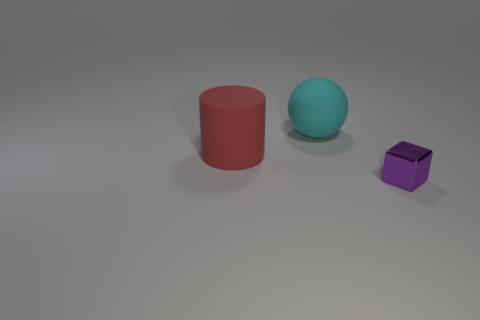There is a large object that is behind the big rubber cylinder; what is its material?
Your answer should be very brief. Rubber. Is there anything else that is made of the same material as the small purple object?
Offer a very short reply. No. Is the number of cylinders left of the shiny thing greater than the number of tiny yellow shiny blocks?
Keep it short and to the point. Yes. Are there any large matte things that are in front of the rubber thing behind the matte object that is left of the sphere?
Your answer should be very brief. Yes. Are there any large red objects right of the cylinder?
Keep it short and to the point. No. What size is the thing right of the big object to the right of the big rubber thing that is in front of the sphere?
Give a very brief answer. Small. How big is the object that is to the right of the big cyan rubber thing?
Your answer should be very brief. Small. How many green objects are cylinders or tiny blocks?
Give a very brief answer. 0. Are there any matte objects that have the same size as the cyan ball?
Give a very brief answer. Yes. Do the thing that is left of the cyan ball and the object behind the red matte cylinder have the same size?
Keep it short and to the point. Yes. 